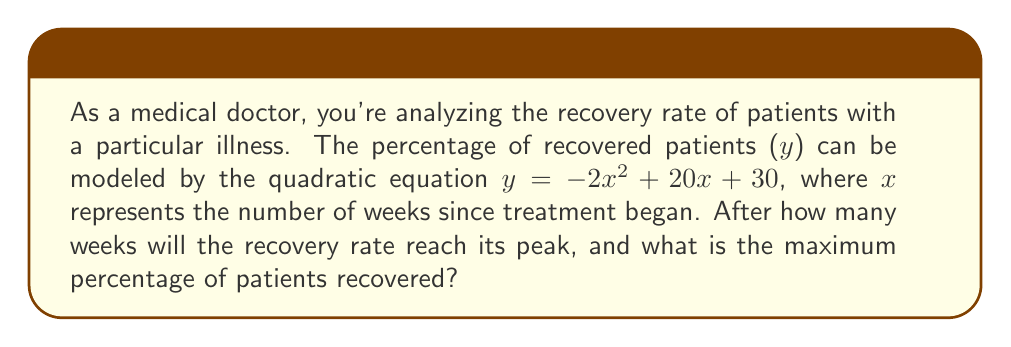Solve this math problem. 1. The given quadratic equation is in the form $y = ax^2 + bx + c$, where:
   $a = -2$, $b = 20$, and $c = 30$

2. To find the peak of the recovery rate, we need to find the vertex of the parabola. The x-coordinate of the vertex represents the number of weeks at which the recovery rate is highest.

3. The formula for the x-coordinate of the vertex is: $x = -\frac{b}{2a}$

4. Substituting the values:
   $x = -\frac{20}{2(-2)} = -\frac{20}{-4} = 5$

5. Therefore, the recovery rate reaches its peak after 5 weeks.

6. To find the maximum percentage of patients recovered, we need to calculate the y-coordinate of the vertex by substituting x = 5 into the original equation:

   $y = -2(5)^2 + 20(5) + 30$
   $y = -2(25) + 100 + 30$
   $y = -50 + 100 + 30$
   $y = 80$

7. Thus, the maximum percentage of patients recovered is 80%.
Answer: 5 weeks; 80% 